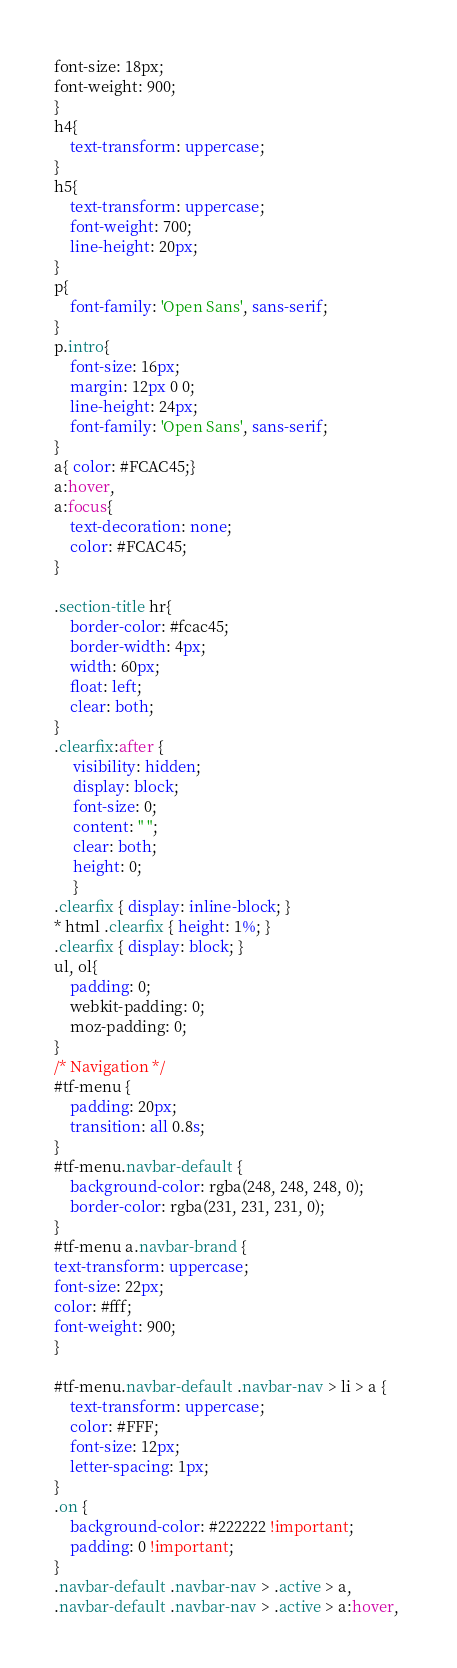Convert code to text. <code><loc_0><loc_0><loc_500><loc_500><_CSS_>font-size: 18px;
font-weight: 900;
}
h4{
	text-transform: uppercase;
}
h5{
	text-transform: uppercase;
	font-weight: 700;
	line-height: 20px;
}
p{
	font-family: 'Open Sans', sans-serif;
}
p.intro{
	font-size: 16px;
	margin: 12px 0 0;
	line-height: 24px;
	font-family: 'Open Sans', sans-serif;
}
a{ color: #FCAC45;}
a:hover,
a:focus{
	text-decoration: none;
	color: #FCAC45;
}

.section-title hr{
	border-color: #fcac45;
	border-width: 4px;
	width: 60px;
	float: left;
	clear: both;
}
.clearfix:after {
     visibility: hidden;
     display: block;
     font-size: 0;
     content: " ";
     clear: both;
     height: 0;
     }
.clearfix { display: inline-block; }
* html .clearfix { height: 1%; }
.clearfix { display: block; }
ul, ol{
	padding: 0;
	webkit-padding: 0;
	moz-padding: 0;
}
/* Navigation */
#tf-menu {
	padding: 20px;
	transition: all 0.8s;
}
#tf-menu.navbar-default {
	background-color: rgba(248, 248, 248, 0);
	border-color: rgba(231, 231, 231, 0);
}
#tf-menu a.navbar-brand {
text-transform: uppercase;
font-size: 22px;
color: #fff;
font-weight: 900;
}

#tf-menu.navbar-default .navbar-nav > li > a {
	text-transform: uppercase;
	color: #FFF;
	font-size: 12px;
	letter-spacing: 1px;
}
.on {
	background-color: #222222 !important;
	padding: 0 !important;
}
.navbar-default .navbar-nav > .active > a, 
.navbar-default .navbar-nav > .active > a:hover, </code> 